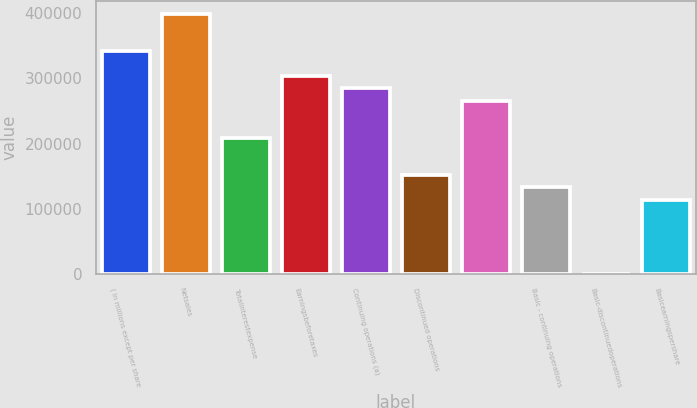Convert chart. <chart><loc_0><loc_0><loc_500><loc_500><bar_chart><fcel>( in millions except per share<fcel>Netsales<fcel>Totalinterestexpense<fcel>Earningsbeforetaxes<fcel>Continuing operations (a)<fcel>Discontinued operations<fcel>Unnamed: 6<fcel>Basic - continuing operations<fcel>Basic-discontinuedoperations<fcel>Basicearningspershare<nl><fcel>341960<fcel>398954<fcel>208976<fcel>303965<fcel>284967<fcel>151982<fcel>265969<fcel>132985<fcel>0.01<fcel>113987<nl></chart> 